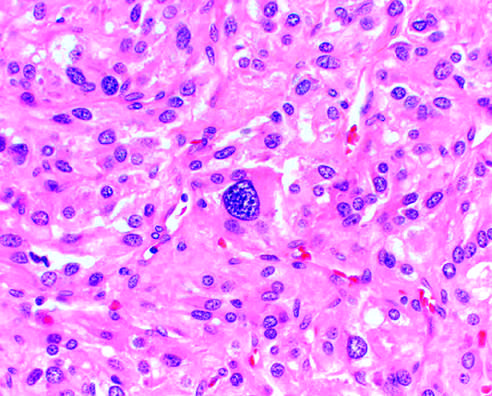s the b-cell antigen receptor complex seen (lower portion)?
Answer the question using a single word or phrase. No 